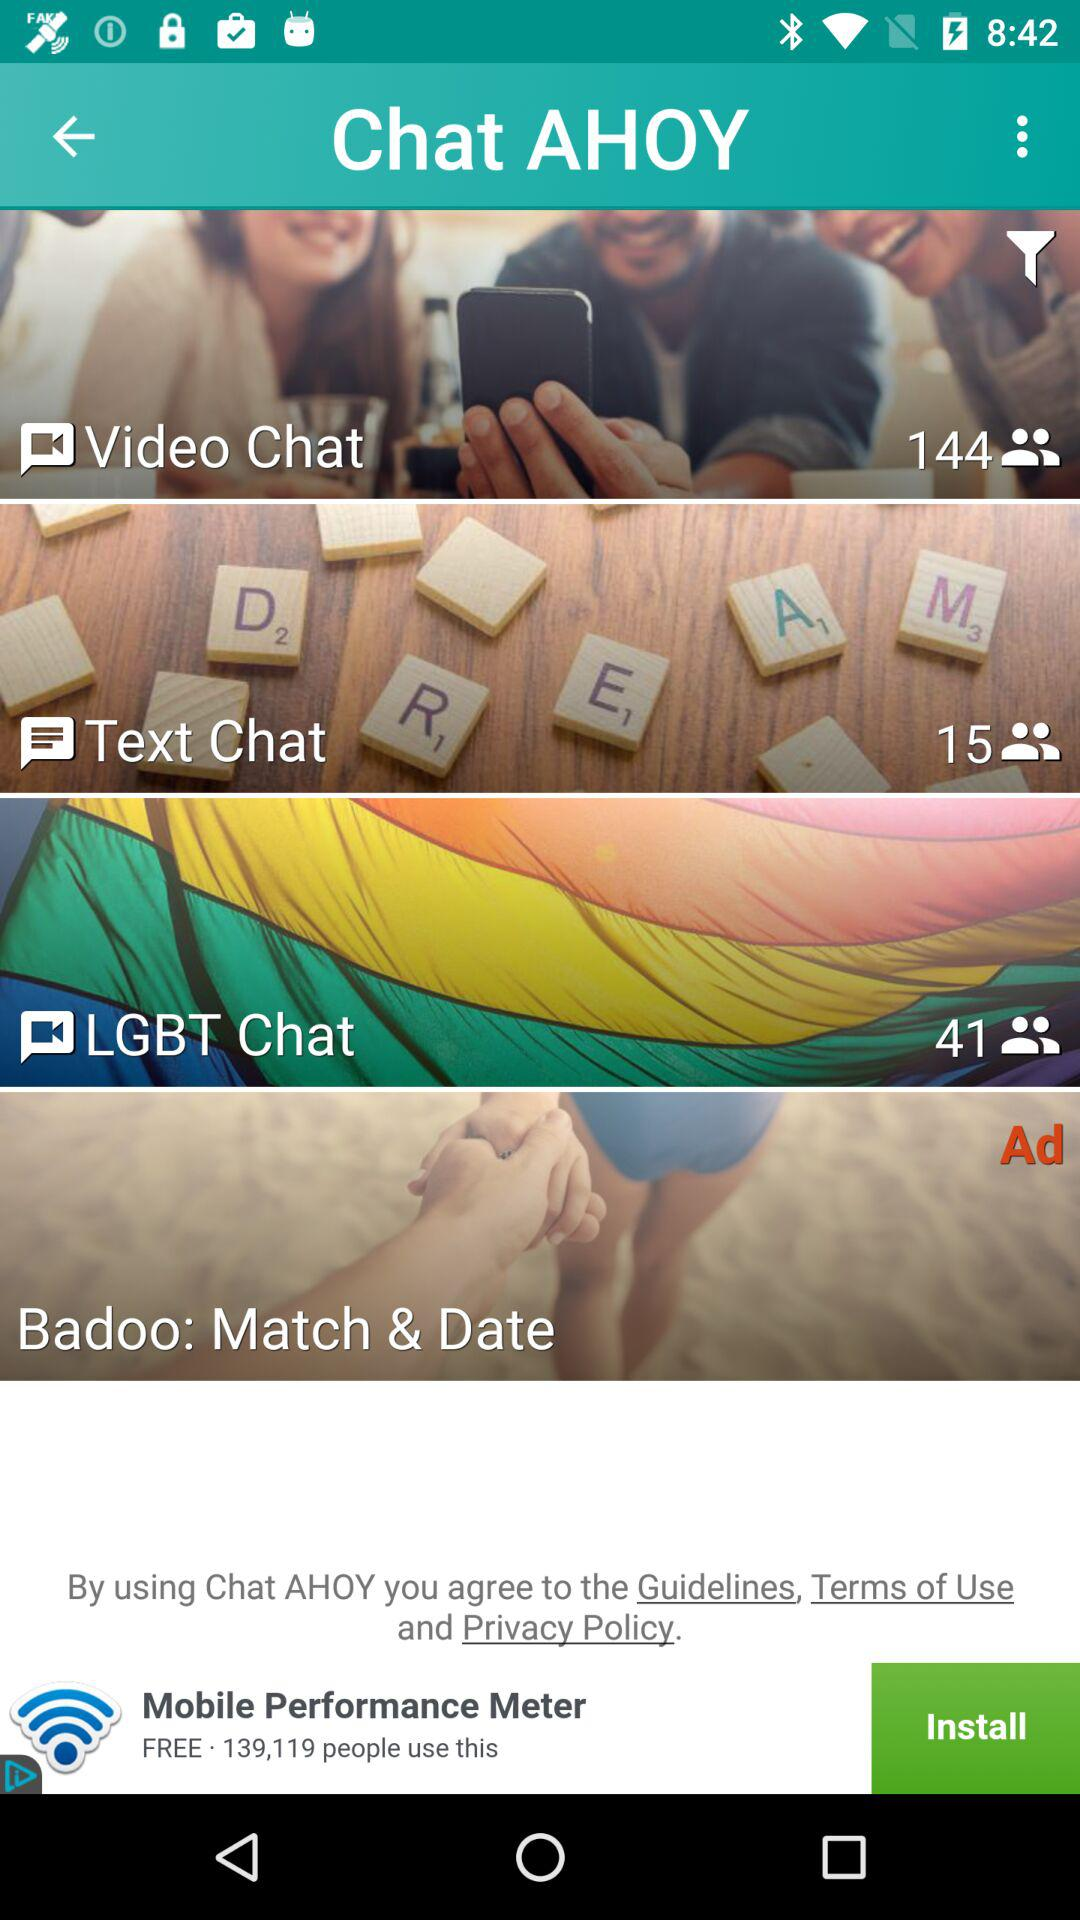What's the total number of users using "LGBT Chat"? The total number of users using "LGBT Chat" is 41. 